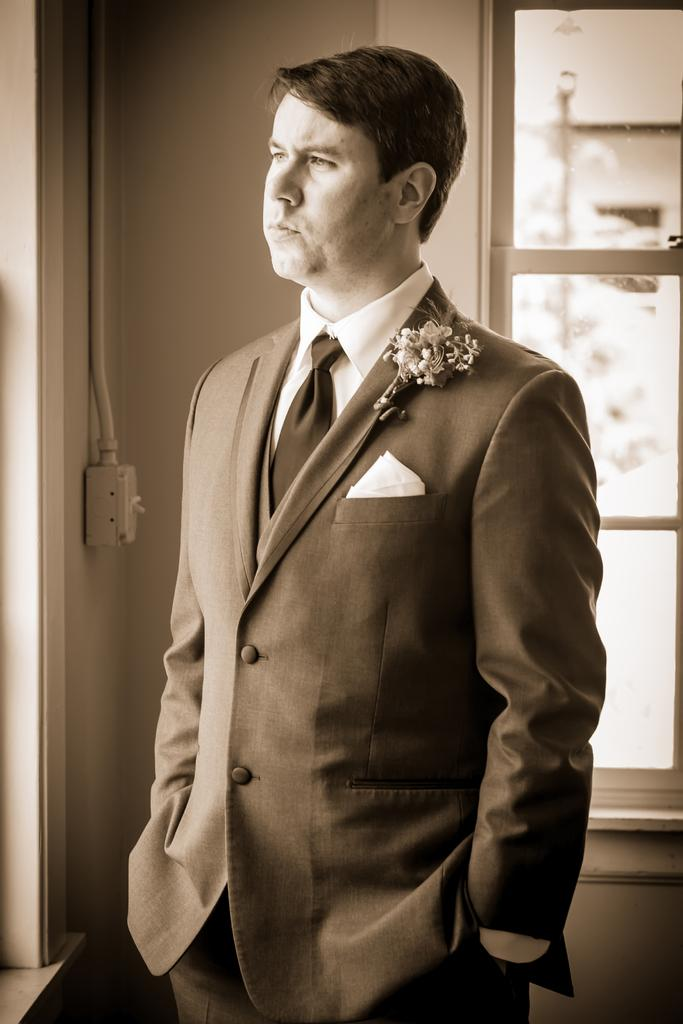What is the main subject of the image? There is a man standing in the image. What can be observed about the man's attire? The man is wearing clothes. What type of material is used for the window in the image? The window in the image is made of glass. What is the purpose of the switchboard in the image? The switchboard is visible in the image, but its purpose is not explicitly stated. What type of structure is present in the image? There is a wall in the image. Can you describe an unusual detail about the man's clothing? There is a napkin in a blazer in the image. What type of sky can be seen through the drawer in the image? There is no drawer present in the image, and therefore no sky can be seen through it. 